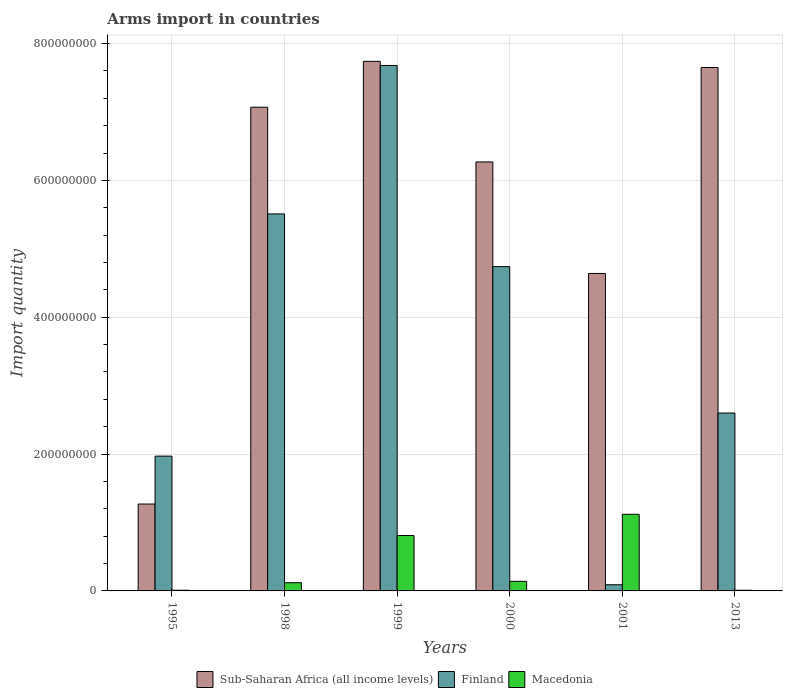How many different coloured bars are there?
Offer a very short reply. 3. How many bars are there on the 4th tick from the right?
Provide a succinct answer. 3. What is the label of the 6th group of bars from the left?
Make the answer very short. 2013. In how many cases, is the number of bars for a given year not equal to the number of legend labels?
Provide a short and direct response. 0. What is the total arms import in Finland in 2000?
Make the answer very short. 4.74e+08. Across all years, what is the maximum total arms import in Macedonia?
Offer a terse response. 1.12e+08. Across all years, what is the minimum total arms import in Macedonia?
Keep it short and to the point. 1.00e+06. In which year was the total arms import in Macedonia minimum?
Keep it short and to the point. 1995. What is the total total arms import in Sub-Saharan Africa (all income levels) in the graph?
Ensure brevity in your answer.  3.46e+09. What is the difference between the total arms import in Finland in 1999 and that in 2013?
Keep it short and to the point. 5.08e+08. What is the difference between the total arms import in Macedonia in 1998 and the total arms import in Finland in 1999?
Provide a short and direct response. -7.56e+08. What is the average total arms import in Sub-Saharan Africa (all income levels) per year?
Make the answer very short. 5.77e+08. In the year 1999, what is the difference between the total arms import in Sub-Saharan Africa (all income levels) and total arms import in Finland?
Offer a terse response. 6.00e+06. In how many years, is the total arms import in Finland greater than 760000000?
Give a very brief answer. 1. What is the ratio of the total arms import in Sub-Saharan Africa (all income levels) in 1995 to that in 2013?
Provide a succinct answer. 0.17. What is the difference between the highest and the second highest total arms import in Sub-Saharan Africa (all income levels)?
Provide a succinct answer. 9.00e+06. What is the difference between the highest and the lowest total arms import in Finland?
Offer a terse response. 7.59e+08. In how many years, is the total arms import in Macedonia greater than the average total arms import in Macedonia taken over all years?
Ensure brevity in your answer.  2. Is the sum of the total arms import in Macedonia in 1999 and 2000 greater than the maximum total arms import in Sub-Saharan Africa (all income levels) across all years?
Give a very brief answer. No. What does the 2nd bar from the left in 1995 represents?
Provide a succinct answer. Finland. How many bars are there?
Ensure brevity in your answer.  18. Are all the bars in the graph horizontal?
Ensure brevity in your answer.  No. Are the values on the major ticks of Y-axis written in scientific E-notation?
Provide a succinct answer. No. Where does the legend appear in the graph?
Make the answer very short. Bottom center. What is the title of the graph?
Give a very brief answer. Arms import in countries. Does "Nicaragua" appear as one of the legend labels in the graph?
Your answer should be compact. No. What is the label or title of the Y-axis?
Your answer should be compact. Import quantity. What is the Import quantity in Sub-Saharan Africa (all income levels) in 1995?
Ensure brevity in your answer.  1.27e+08. What is the Import quantity in Finland in 1995?
Offer a terse response. 1.97e+08. What is the Import quantity of Sub-Saharan Africa (all income levels) in 1998?
Make the answer very short. 7.07e+08. What is the Import quantity of Finland in 1998?
Your response must be concise. 5.51e+08. What is the Import quantity of Macedonia in 1998?
Your answer should be compact. 1.20e+07. What is the Import quantity of Sub-Saharan Africa (all income levels) in 1999?
Offer a terse response. 7.74e+08. What is the Import quantity of Finland in 1999?
Offer a very short reply. 7.68e+08. What is the Import quantity of Macedonia in 1999?
Give a very brief answer. 8.10e+07. What is the Import quantity of Sub-Saharan Africa (all income levels) in 2000?
Keep it short and to the point. 6.27e+08. What is the Import quantity in Finland in 2000?
Your answer should be very brief. 4.74e+08. What is the Import quantity in Macedonia in 2000?
Ensure brevity in your answer.  1.40e+07. What is the Import quantity in Sub-Saharan Africa (all income levels) in 2001?
Your answer should be compact. 4.64e+08. What is the Import quantity in Finland in 2001?
Make the answer very short. 9.00e+06. What is the Import quantity of Macedonia in 2001?
Give a very brief answer. 1.12e+08. What is the Import quantity in Sub-Saharan Africa (all income levels) in 2013?
Make the answer very short. 7.65e+08. What is the Import quantity in Finland in 2013?
Offer a terse response. 2.60e+08. Across all years, what is the maximum Import quantity in Sub-Saharan Africa (all income levels)?
Provide a succinct answer. 7.74e+08. Across all years, what is the maximum Import quantity in Finland?
Offer a terse response. 7.68e+08. Across all years, what is the maximum Import quantity of Macedonia?
Your answer should be compact. 1.12e+08. Across all years, what is the minimum Import quantity of Sub-Saharan Africa (all income levels)?
Offer a terse response. 1.27e+08. Across all years, what is the minimum Import quantity in Finland?
Your answer should be compact. 9.00e+06. Across all years, what is the minimum Import quantity in Macedonia?
Your answer should be compact. 1.00e+06. What is the total Import quantity of Sub-Saharan Africa (all income levels) in the graph?
Offer a terse response. 3.46e+09. What is the total Import quantity in Finland in the graph?
Offer a terse response. 2.26e+09. What is the total Import quantity of Macedonia in the graph?
Provide a short and direct response. 2.21e+08. What is the difference between the Import quantity of Sub-Saharan Africa (all income levels) in 1995 and that in 1998?
Offer a terse response. -5.80e+08. What is the difference between the Import quantity in Finland in 1995 and that in 1998?
Give a very brief answer. -3.54e+08. What is the difference between the Import quantity of Macedonia in 1995 and that in 1998?
Offer a terse response. -1.10e+07. What is the difference between the Import quantity in Sub-Saharan Africa (all income levels) in 1995 and that in 1999?
Provide a short and direct response. -6.47e+08. What is the difference between the Import quantity in Finland in 1995 and that in 1999?
Give a very brief answer. -5.71e+08. What is the difference between the Import quantity in Macedonia in 1995 and that in 1999?
Offer a very short reply. -8.00e+07. What is the difference between the Import quantity of Sub-Saharan Africa (all income levels) in 1995 and that in 2000?
Make the answer very short. -5.00e+08. What is the difference between the Import quantity in Finland in 1995 and that in 2000?
Your answer should be compact. -2.77e+08. What is the difference between the Import quantity of Macedonia in 1995 and that in 2000?
Keep it short and to the point. -1.30e+07. What is the difference between the Import quantity of Sub-Saharan Africa (all income levels) in 1995 and that in 2001?
Make the answer very short. -3.37e+08. What is the difference between the Import quantity in Finland in 1995 and that in 2001?
Your answer should be compact. 1.88e+08. What is the difference between the Import quantity of Macedonia in 1995 and that in 2001?
Provide a succinct answer. -1.11e+08. What is the difference between the Import quantity in Sub-Saharan Africa (all income levels) in 1995 and that in 2013?
Offer a terse response. -6.38e+08. What is the difference between the Import quantity in Finland in 1995 and that in 2013?
Give a very brief answer. -6.30e+07. What is the difference between the Import quantity in Macedonia in 1995 and that in 2013?
Your answer should be compact. 0. What is the difference between the Import quantity in Sub-Saharan Africa (all income levels) in 1998 and that in 1999?
Give a very brief answer. -6.70e+07. What is the difference between the Import quantity in Finland in 1998 and that in 1999?
Keep it short and to the point. -2.17e+08. What is the difference between the Import quantity of Macedonia in 1998 and that in 1999?
Offer a very short reply. -6.90e+07. What is the difference between the Import quantity of Sub-Saharan Africa (all income levels) in 1998 and that in 2000?
Offer a very short reply. 8.00e+07. What is the difference between the Import quantity of Finland in 1998 and that in 2000?
Provide a short and direct response. 7.70e+07. What is the difference between the Import quantity of Sub-Saharan Africa (all income levels) in 1998 and that in 2001?
Your response must be concise. 2.43e+08. What is the difference between the Import quantity in Finland in 1998 and that in 2001?
Your answer should be compact. 5.42e+08. What is the difference between the Import quantity in Macedonia in 1998 and that in 2001?
Provide a succinct answer. -1.00e+08. What is the difference between the Import quantity of Sub-Saharan Africa (all income levels) in 1998 and that in 2013?
Give a very brief answer. -5.80e+07. What is the difference between the Import quantity of Finland in 1998 and that in 2013?
Your answer should be compact. 2.91e+08. What is the difference between the Import quantity of Macedonia in 1998 and that in 2013?
Keep it short and to the point. 1.10e+07. What is the difference between the Import quantity of Sub-Saharan Africa (all income levels) in 1999 and that in 2000?
Your response must be concise. 1.47e+08. What is the difference between the Import quantity of Finland in 1999 and that in 2000?
Your answer should be compact. 2.94e+08. What is the difference between the Import quantity in Macedonia in 1999 and that in 2000?
Make the answer very short. 6.70e+07. What is the difference between the Import quantity of Sub-Saharan Africa (all income levels) in 1999 and that in 2001?
Provide a succinct answer. 3.10e+08. What is the difference between the Import quantity of Finland in 1999 and that in 2001?
Provide a short and direct response. 7.59e+08. What is the difference between the Import quantity in Macedonia in 1999 and that in 2001?
Give a very brief answer. -3.10e+07. What is the difference between the Import quantity in Sub-Saharan Africa (all income levels) in 1999 and that in 2013?
Give a very brief answer. 9.00e+06. What is the difference between the Import quantity in Finland in 1999 and that in 2013?
Keep it short and to the point. 5.08e+08. What is the difference between the Import quantity in Macedonia in 1999 and that in 2013?
Your answer should be compact. 8.00e+07. What is the difference between the Import quantity in Sub-Saharan Africa (all income levels) in 2000 and that in 2001?
Give a very brief answer. 1.63e+08. What is the difference between the Import quantity of Finland in 2000 and that in 2001?
Your answer should be very brief. 4.65e+08. What is the difference between the Import quantity of Macedonia in 2000 and that in 2001?
Offer a terse response. -9.80e+07. What is the difference between the Import quantity in Sub-Saharan Africa (all income levels) in 2000 and that in 2013?
Offer a terse response. -1.38e+08. What is the difference between the Import quantity in Finland in 2000 and that in 2013?
Keep it short and to the point. 2.14e+08. What is the difference between the Import quantity of Macedonia in 2000 and that in 2013?
Provide a short and direct response. 1.30e+07. What is the difference between the Import quantity of Sub-Saharan Africa (all income levels) in 2001 and that in 2013?
Offer a terse response. -3.01e+08. What is the difference between the Import quantity of Finland in 2001 and that in 2013?
Provide a short and direct response. -2.51e+08. What is the difference between the Import quantity in Macedonia in 2001 and that in 2013?
Make the answer very short. 1.11e+08. What is the difference between the Import quantity in Sub-Saharan Africa (all income levels) in 1995 and the Import quantity in Finland in 1998?
Make the answer very short. -4.24e+08. What is the difference between the Import quantity of Sub-Saharan Africa (all income levels) in 1995 and the Import quantity of Macedonia in 1998?
Offer a very short reply. 1.15e+08. What is the difference between the Import quantity of Finland in 1995 and the Import quantity of Macedonia in 1998?
Give a very brief answer. 1.85e+08. What is the difference between the Import quantity in Sub-Saharan Africa (all income levels) in 1995 and the Import quantity in Finland in 1999?
Your answer should be compact. -6.41e+08. What is the difference between the Import quantity of Sub-Saharan Africa (all income levels) in 1995 and the Import quantity of Macedonia in 1999?
Your answer should be very brief. 4.60e+07. What is the difference between the Import quantity of Finland in 1995 and the Import quantity of Macedonia in 1999?
Keep it short and to the point. 1.16e+08. What is the difference between the Import quantity of Sub-Saharan Africa (all income levels) in 1995 and the Import quantity of Finland in 2000?
Keep it short and to the point. -3.47e+08. What is the difference between the Import quantity of Sub-Saharan Africa (all income levels) in 1995 and the Import quantity of Macedonia in 2000?
Provide a succinct answer. 1.13e+08. What is the difference between the Import quantity of Finland in 1995 and the Import quantity of Macedonia in 2000?
Keep it short and to the point. 1.83e+08. What is the difference between the Import quantity of Sub-Saharan Africa (all income levels) in 1995 and the Import quantity of Finland in 2001?
Provide a short and direct response. 1.18e+08. What is the difference between the Import quantity in Sub-Saharan Africa (all income levels) in 1995 and the Import quantity in Macedonia in 2001?
Ensure brevity in your answer.  1.50e+07. What is the difference between the Import quantity of Finland in 1995 and the Import quantity of Macedonia in 2001?
Your answer should be very brief. 8.50e+07. What is the difference between the Import quantity of Sub-Saharan Africa (all income levels) in 1995 and the Import quantity of Finland in 2013?
Make the answer very short. -1.33e+08. What is the difference between the Import quantity in Sub-Saharan Africa (all income levels) in 1995 and the Import quantity in Macedonia in 2013?
Offer a very short reply. 1.26e+08. What is the difference between the Import quantity of Finland in 1995 and the Import quantity of Macedonia in 2013?
Your response must be concise. 1.96e+08. What is the difference between the Import quantity in Sub-Saharan Africa (all income levels) in 1998 and the Import quantity in Finland in 1999?
Your response must be concise. -6.10e+07. What is the difference between the Import quantity of Sub-Saharan Africa (all income levels) in 1998 and the Import quantity of Macedonia in 1999?
Ensure brevity in your answer.  6.26e+08. What is the difference between the Import quantity of Finland in 1998 and the Import quantity of Macedonia in 1999?
Give a very brief answer. 4.70e+08. What is the difference between the Import quantity of Sub-Saharan Africa (all income levels) in 1998 and the Import quantity of Finland in 2000?
Keep it short and to the point. 2.33e+08. What is the difference between the Import quantity of Sub-Saharan Africa (all income levels) in 1998 and the Import quantity of Macedonia in 2000?
Make the answer very short. 6.93e+08. What is the difference between the Import quantity of Finland in 1998 and the Import quantity of Macedonia in 2000?
Offer a terse response. 5.37e+08. What is the difference between the Import quantity in Sub-Saharan Africa (all income levels) in 1998 and the Import quantity in Finland in 2001?
Ensure brevity in your answer.  6.98e+08. What is the difference between the Import quantity in Sub-Saharan Africa (all income levels) in 1998 and the Import quantity in Macedonia in 2001?
Your answer should be compact. 5.95e+08. What is the difference between the Import quantity of Finland in 1998 and the Import quantity of Macedonia in 2001?
Ensure brevity in your answer.  4.39e+08. What is the difference between the Import quantity of Sub-Saharan Africa (all income levels) in 1998 and the Import quantity of Finland in 2013?
Offer a terse response. 4.47e+08. What is the difference between the Import quantity of Sub-Saharan Africa (all income levels) in 1998 and the Import quantity of Macedonia in 2013?
Your answer should be compact. 7.06e+08. What is the difference between the Import quantity of Finland in 1998 and the Import quantity of Macedonia in 2013?
Provide a succinct answer. 5.50e+08. What is the difference between the Import quantity of Sub-Saharan Africa (all income levels) in 1999 and the Import quantity of Finland in 2000?
Provide a succinct answer. 3.00e+08. What is the difference between the Import quantity of Sub-Saharan Africa (all income levels) in 1999 and the Import quantity of Macedonia in 2000?
Make the answer very short. 7.60e+08. What is the difference between the Import quantity of Finland in 1999 and the Import quantity of Macedonia in 2000?
Provide a short and direct response. 7.54e+08. What is the difference between the Import quantity in Sub-Saharan Africa (all income levels) in 1999 and the Import quantity in Finland in 2001?
Keep it short and to the point. 7.65e+08. What is the difference between the Import quantity of Sub-Saharan Africa (all income levels) in 1999 and the Import quantity of Macedonia in 2001?
Your answer should be compact. 6.62e+08. What is the difference between the Import quantity in Finland in 1999 and the Import quantity in Macedonia in 2001?
Your answer should be very brief. 6.56e+08. What is the difference between the Import quantity in Sub-Saharan Africa (all income levels) in 1999 and the Import quantity in Finland in 2013?
Provide a short and direct response. 5.14e+08. What is the difference between the Import quantity of Sub-Saharan Africa (all income levels) in 1999 and the Import quantity of Macedonia in 2013?
Ensure brevity in your answer.  7.73e+08. What is the difference between the Import quantity in Finland in 1999 and the Import quantity in Macedonia in 2013?
Your answer should be compact. 7.67e+08. What is the difference between the Import quantity of Sub-Saharan Africa (all income levels) in 2000 and the Import quantity of Finland in 2001?
Offer a terse response. 6.18e+08. What is the difference between the Import quantity of Sub-Saharan Africa (all income levels) in 2000 and the Import quantity of Macedonia in 2001?
Your answer should be very brief. 5.15e+08. What is the difference between the Import quantity of Finland in 2000 and the Import quantity of Macedonia in 2001?
Ensure brevity in your answer.  3.62e+08. What is the difference between the Import quantity in Sub-Saharan Africa (all income levels) in 2000 and the Import quantity in Finland in 2013?
Your answer should be very brief. 3.67e+08. What is the difference between the Import quantity in Sub-Saharan Africa (all income levels) in 2000 and the Import quantity in Macedonia in 2013?
Your answer should be compact. 6.26e+08. What is the difference between the Import quantity in Finland in 2000 and the Import quantity in Macedonia in 2013?
Make the answer very short. 4.73e+08. What is the difference between the Import quantity in Sub-Saharan Africa (all income levels) in 2001 and the Import quantity in Finland in 2013?
Ensure brevity in your answer.  2.04e+08. What is the difference between the Import quantity in Sub-Saharan Africa (all income levels) in 2001 and the Import quantity in Macedonia in 2013?
Provide a short and direct response. 4.63e+08. What is the average Import quantity of Sub-Saharan Africa (all income levels) per year?
Give a very brief answer. 5.77e+08. What is the average Import quantity in Finland per year?
Provide a succinct answer. 3.76e+08. What is the average Import quantity in Macedonia per year?
Offer a terse response. 3.68e+07. In the year 1995, what is the difference between the Import quantity of Sub-Saharan Africa (all income levels) and Import quantity of Finland?
Provide a succinct answer. -7.00e+07. In the year 1995, what is the difference between the Import quantity of Sub-Saharan Africa (all income levels) and Import quantity of Macedonia?
Make the answer very short. 1.26e+08. In the year 1995, what is the difference between the Import quantity in Finland and Import quantity in Macedonia?
Offer a very short reply. 1.96e+08. In the year 1998, what is the difference between the Import quantity of Sub-Saharan Africa (all income levels) and Import quantity of Finland?
Keep it short and to the point. 1.56e+08. In the year 1998, what is the difference between the Import quantity in Sub-Saharan Africa (all income levels) and Import quantity in Macedonia?
Your answer should be very brief. 6.95e+08. In the year 1998, what is the difference between the Import quantity of Finland and Import quantity of Macedonia?
Make the answer very short. 5.39e+08. In the year 1999, what is the difference between the Import quantity in Sub-Saharan Africa (all income levels) and Import quantity in Finland?
Offer a terse response. 6.00e+06. In the year 1999, what is the difference between the Import quantity of Sub-Saharan Africa (all income levels) and Import quantity of Macedonia?
Make the answer very short. 6.93e+08. In the year 1999, what is the difference between the Import quantity of Finland and Import quantity of Macedonia?
Offer a terse response. 6.87e+08. In the year 2000, what is the difference between the Import quantity in Sub-Saharan Africa (all income levels) and Import quantity in Finland?
Your answer should be compact. 1.53e+08. In the year 2000, what is the difference between the Import quantity of Sub-Saharan Africa (all income levels) and Import quantity of Macedonia?
Ensure brevity in your answer.  6.13e+08. In the year 2000, what is the difference between the Import quantity of Finland and Import quantity of Macedonia?
Your answer should be compact. 4.60e+08. In the year 2001, what is the difference between the Import quantity in Sub-Saharan Africa (all income levels) and Import quantity in Finland?
Your answer should be compact. 4.55e+08. In the year 2001, what is the difference between the Import quantity of Sub-Saharan Africa (all income levels) and Import quantity of Macedonia?
Keep it short and to the point. 3.52e+08. In the year 2001, what is the difference between the Import quantity in Finland and Import quantity in Macedonia?
Offer a terse response. -1.03e+08. In the year 2013, what is the difference between the Import quantity of Sub-Saharan Africa (all income levels) and Import quantity of Finland?
Provide a succinct answer. 5.05e+08. In the year 2013, what is the difference between the Import quantity in Sub-Saharan Africa (all income levels) and Import quantity in Macedonia?
Make the answer very short. 7.64e+08. In the year 2013, what is the difference between the Import quantity of Finland and Import quantity of Macedonia?
Offer a very short reply. 2.59e+08. What is the ratio of the Import quantity in Sub-Saharan Africa (all income levels) in 1995 to that in 1998?
Offer a terse response. 0.18. What is the ratio of the Import quantity of Finland in 1995 to that in 1998?
Give a very brief answer. 0.36. What is the ratio of the Import quantity of Macedonia in 1995 to that in 1998?
Your answer should be compact. 0.08. What is the ratio of the Import quantity of Sub-Saharan Africa (all income levels) in 1995 to that in 1999?
Provide a succinct answer. 0.16. What is the ratio of the Import quantity in Finland in 1995 to that in 1999?
Offer a very short reply. 0.26. What is the ratio of the Import quantity of Macedonia in 1995 to that in 1999?
Make the answer very short. 0.01. What is the ratio of the Import quantity in Sub-Saharan Africa (all income levels) in 1995 to that in 2000?
Your answer should be very brief. 0.2. What is the ratio of the Import quantity of Finland in 1995 to that in 2000?
Provide a short and direct response. 0.42. What is the ratio of the Import quantity in Macedonia in 1995 to that in 2000?
Provide a succinct answer. 0.07. What is the ratio of the Import quantity in Sub-Saharan Africa (all income levels) in 1995 to that in 2001?
Your answer should be compact. 0.27. What is the ratio of the Import quantity of Finland in 1995 to that in 2001?
Make the answer very short. 21.89. What is the ratio of the Import quantity of Macedonia in 1995 to that in 2001?
Your answer should be very brief. 0.01. What is the ratio of the Import quantity of Sub-Saharan Africa (all income levels) in 1995 to that in 2013?
Keep it short and to the point. 0.17. What is the ratio of the Import quantity in Finland in 1995 to that in 2013?
Keep it short and to the point. 0.76. What is the ratio of the Import quantity in Macedonia in 1995 to that in 2013?
Offer a very short reply. 1. What is the ratio of the Import quantity of Sub-Saharan Africa (all income levels) in 1998 to that in 1999?
Provide a succinct answer. 0.91. What is the ratio of the Import quantity of Finland in 1998 to that in 1999?
Make the answer very short. 0.72. What is the ratio of the Import quantity of Macedonia in 1998 to that in 1999?
Your answer should be compact. 0.15. What is the ratio of the Import quantity in Sub-Saharan Africa (all income levels) in 1998 to that in 2000?
Provide a short and direct response. 1.13. What is the ratio of the Import quantity in Finland in 1998 to that in 2000?
Give a very brief answer. 1.16. What is the ratio of the Import quantity in Sub-Saharan Africa (all income levels) in 1998 to that in 2001?
Make the answer very short. 1.52. What is the ratio of the Import quantity of Finland in 1998 to that in 2001?
Ensure brevity in your answer.  61.22. What is the ratio of the Import quantity of Macedonia in 1998 to that in 2001?
Give a very brief answer. 0.11. What is the ratio of the Import quantity in Sub-Saharan Africa (all income levels) in 1998 to that in 2013?
Ensure brevity in your answer.  0.92. What is the ratio of the Import quantity in Finland in 1998 to that in 2013?
Your answer should be very brief. 2.12. What is the ratio of the Import quantity in Macedonia in 1998 to that in 2013?
Offer a terse response. 12. What is the ratio of the Import quantity of Sub-Saharan Africa (all income levels) in 1999 to that in 2000?
Give a very brief answer. 1.23. What is the ratio of the Import quantity in Finland in 1999 to that in 2000?
Offer a terse response. 1.62. What is the ratio of the Import quantity in Macedonia in 1999 to that in 2000?
Provide a succinct answer. 5.79. What is the ratio of the Import quantity in Sub-Saharan Africa (all income levels) in 1999 to that in 2001?
Offer a very short reply. 1.67. What is the ratio of the Import quantity of Finland in 1999 to that in 2001?
Ensure brevity in your answer.  85.33. What is the ratio of the Import quantity in Macedonia in 1999 to that in 2001?
Keep it short and to the point. 0.72. What is the ratio of the Import quantity in Sub-Saharan Africa (all income levels) in 1999 to that in 2013?
Your answer should be compact. 1.01. What is the ratio of the Import quantity in Finland in 1999 to that in 2013?
Provide a succinct answer. 2.95. What is the ratio of the Import quantity of Macedonia in 1999 to that in 2013?
Your response must be concise. 81. What is the ratio of the Import quantity of Sub-Saharan Africa (all income levels) in 2000 to that in 2001?
Provide a succinct answer. 1.35. What is the ratio of the Import quantity in Finland in 2000 to that in 2001?
Your answer should be very brief. 52.67. What is the ratio of the Import quantity of Sub-Saharan Africa (all income levels) in 2000 to that in 2013?
Offer a very short reply. 0.82. What is the ratio of the Import quantity in Finland in 2000 to that in 2013?
Offer a terse response. 1.82. What is the ratio of the Import quantity of Macedonia in 2000 to that in 2013?
Your answer should be compact. 14. What is the ratio of the Import quantity in Sub-Saharan Africa (all income levels) in 2001 to that in 2013?
Make the answer very short. 0.61. What is the ratio of the Import quantity in Finland in 2001 to that in 2013?
Your answer should be very brief. 0.03. What is the ratio of the Import quantity of Macedonia in 2001 to that in 2013?
Provide a short and direct response. 112. What is the difference between the highest and the second highest Import quantity in Sub-Saharan Africa (all income levels)?
Provide a short and direct response. 9.00e+06. What is the difference between the highest and the second highest Import quantity of Finland?
Your answer should be compact. 2.17e+08. What is the difference between the highest and the second highest Import quantity of Macedonia?
Provide a succinct answer. 3.10e+07. What is the difference between the highest and the lowest Import quantity in Sub-Saharan Africa (all income levels)?
Your answer should be very brief. 6.47e+08. What is the difference between the highest and the lowest Import quantity of Finland?
Offer a very short reply. 7.59e+08. What is the difference between the highest and the lowest Import quantity of Macedonia?
Provide a succinct answer. 1.11e+08. 